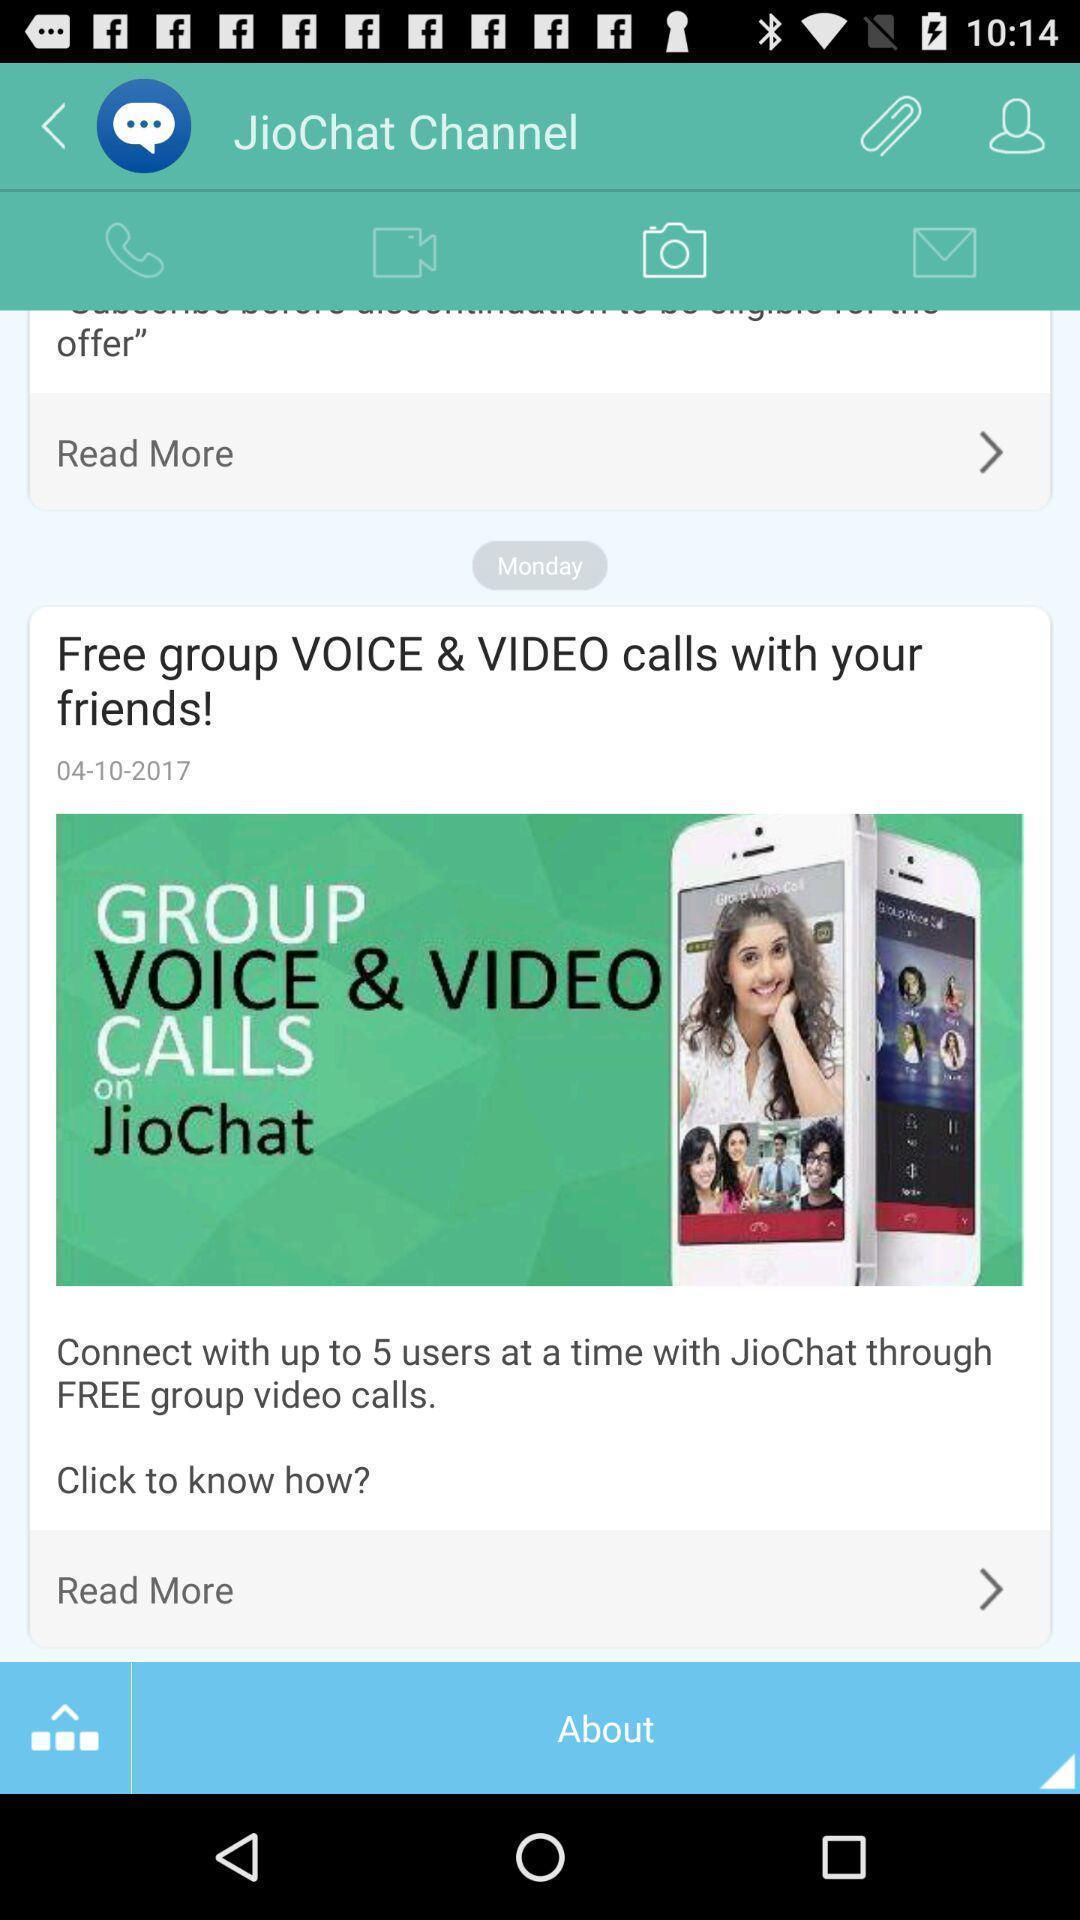Provide a textual representation of this image. Screen shows options for jiochat channel. 